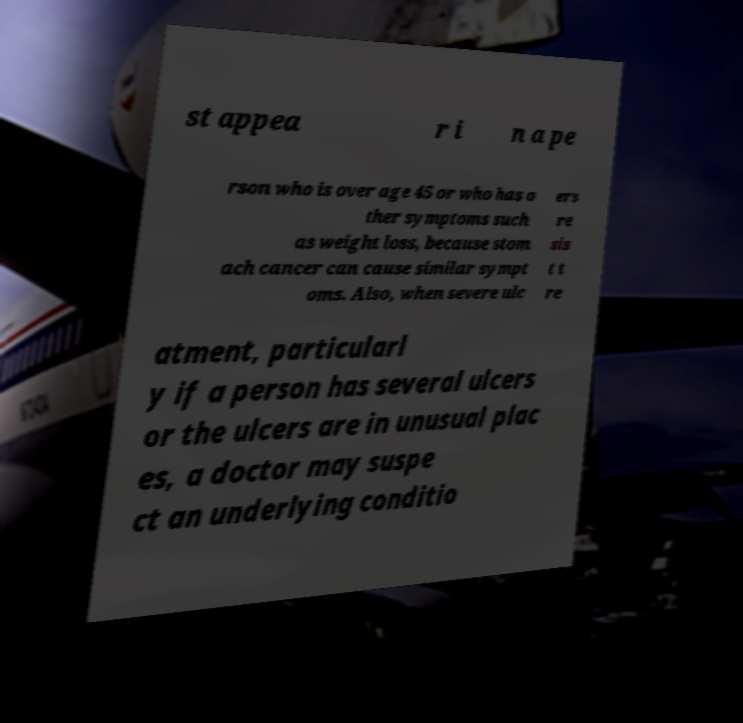I need the written content from this picture converted into text. Can you do that? st appea r i n a pe rson who is over age 45 or who has o ther symptoms such as weight loss, because stom ach cancer can cause similar sympt oms. Also, when severe ulc ers re sis t t re atment, particularl y if a person has several ulcers or the ulcers are in unusual plac es, a doctor may suspe ct an underlying conditio 